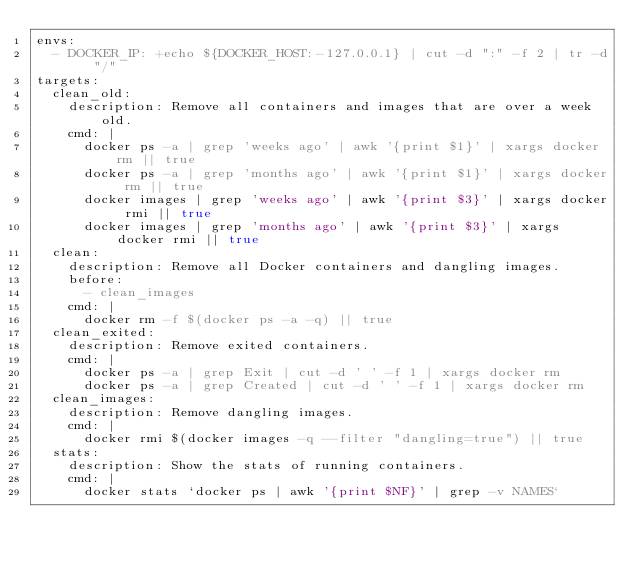<code> <loc_0><loc_0><loc_500><loc_500><_YAML_>envs:
  - DOCKER_IP: +echo ${DOCKER_HOST:-127.0.0.1} | cut -d ":" -f 2 | tr -d "/"
targets:
  clean_old:
    description: Remove all containers and images that are over a week old.
    cmd: |
      docker ps -a | grep 'weeks ago' | awk '{print $1}' | xargs docker rm || true
      docker ps -a | grep 'months ago' | awk '{print $1}' | xargs docker rm || true
      docker images | grep 'weeks ago' | awk '{print $3}' | xargs docker rmi || true
      docker images | grep 'months ago' | awk '{print $3}' | xargs docker rmi || true
  clean:
    description: Remove all Docker containers and dangling images.
    before:
      - clean_images
    cmd: |
      docker rm -f $(docker ps -a -q) || true
  clean_exited:
    description: Remove exited containers.
    cmd: |
      docker ps -a | grep Exit | cut -d ' ' -f 1 | xargs docker rm
      docker ps -a | grep Created | cut -d ' ' -f 1 | xargs docker rm
  clean_images:
    description: Remove dangling images.
    cmd: |
      docker rmi $(docker images -q --filter "dangling=true") || true
  stats:
    description: Show the stats of running containers.
    cmd: |
      docker stats `docker ps | awk '{print $NF}' | grep -v NAMES`
</code> 